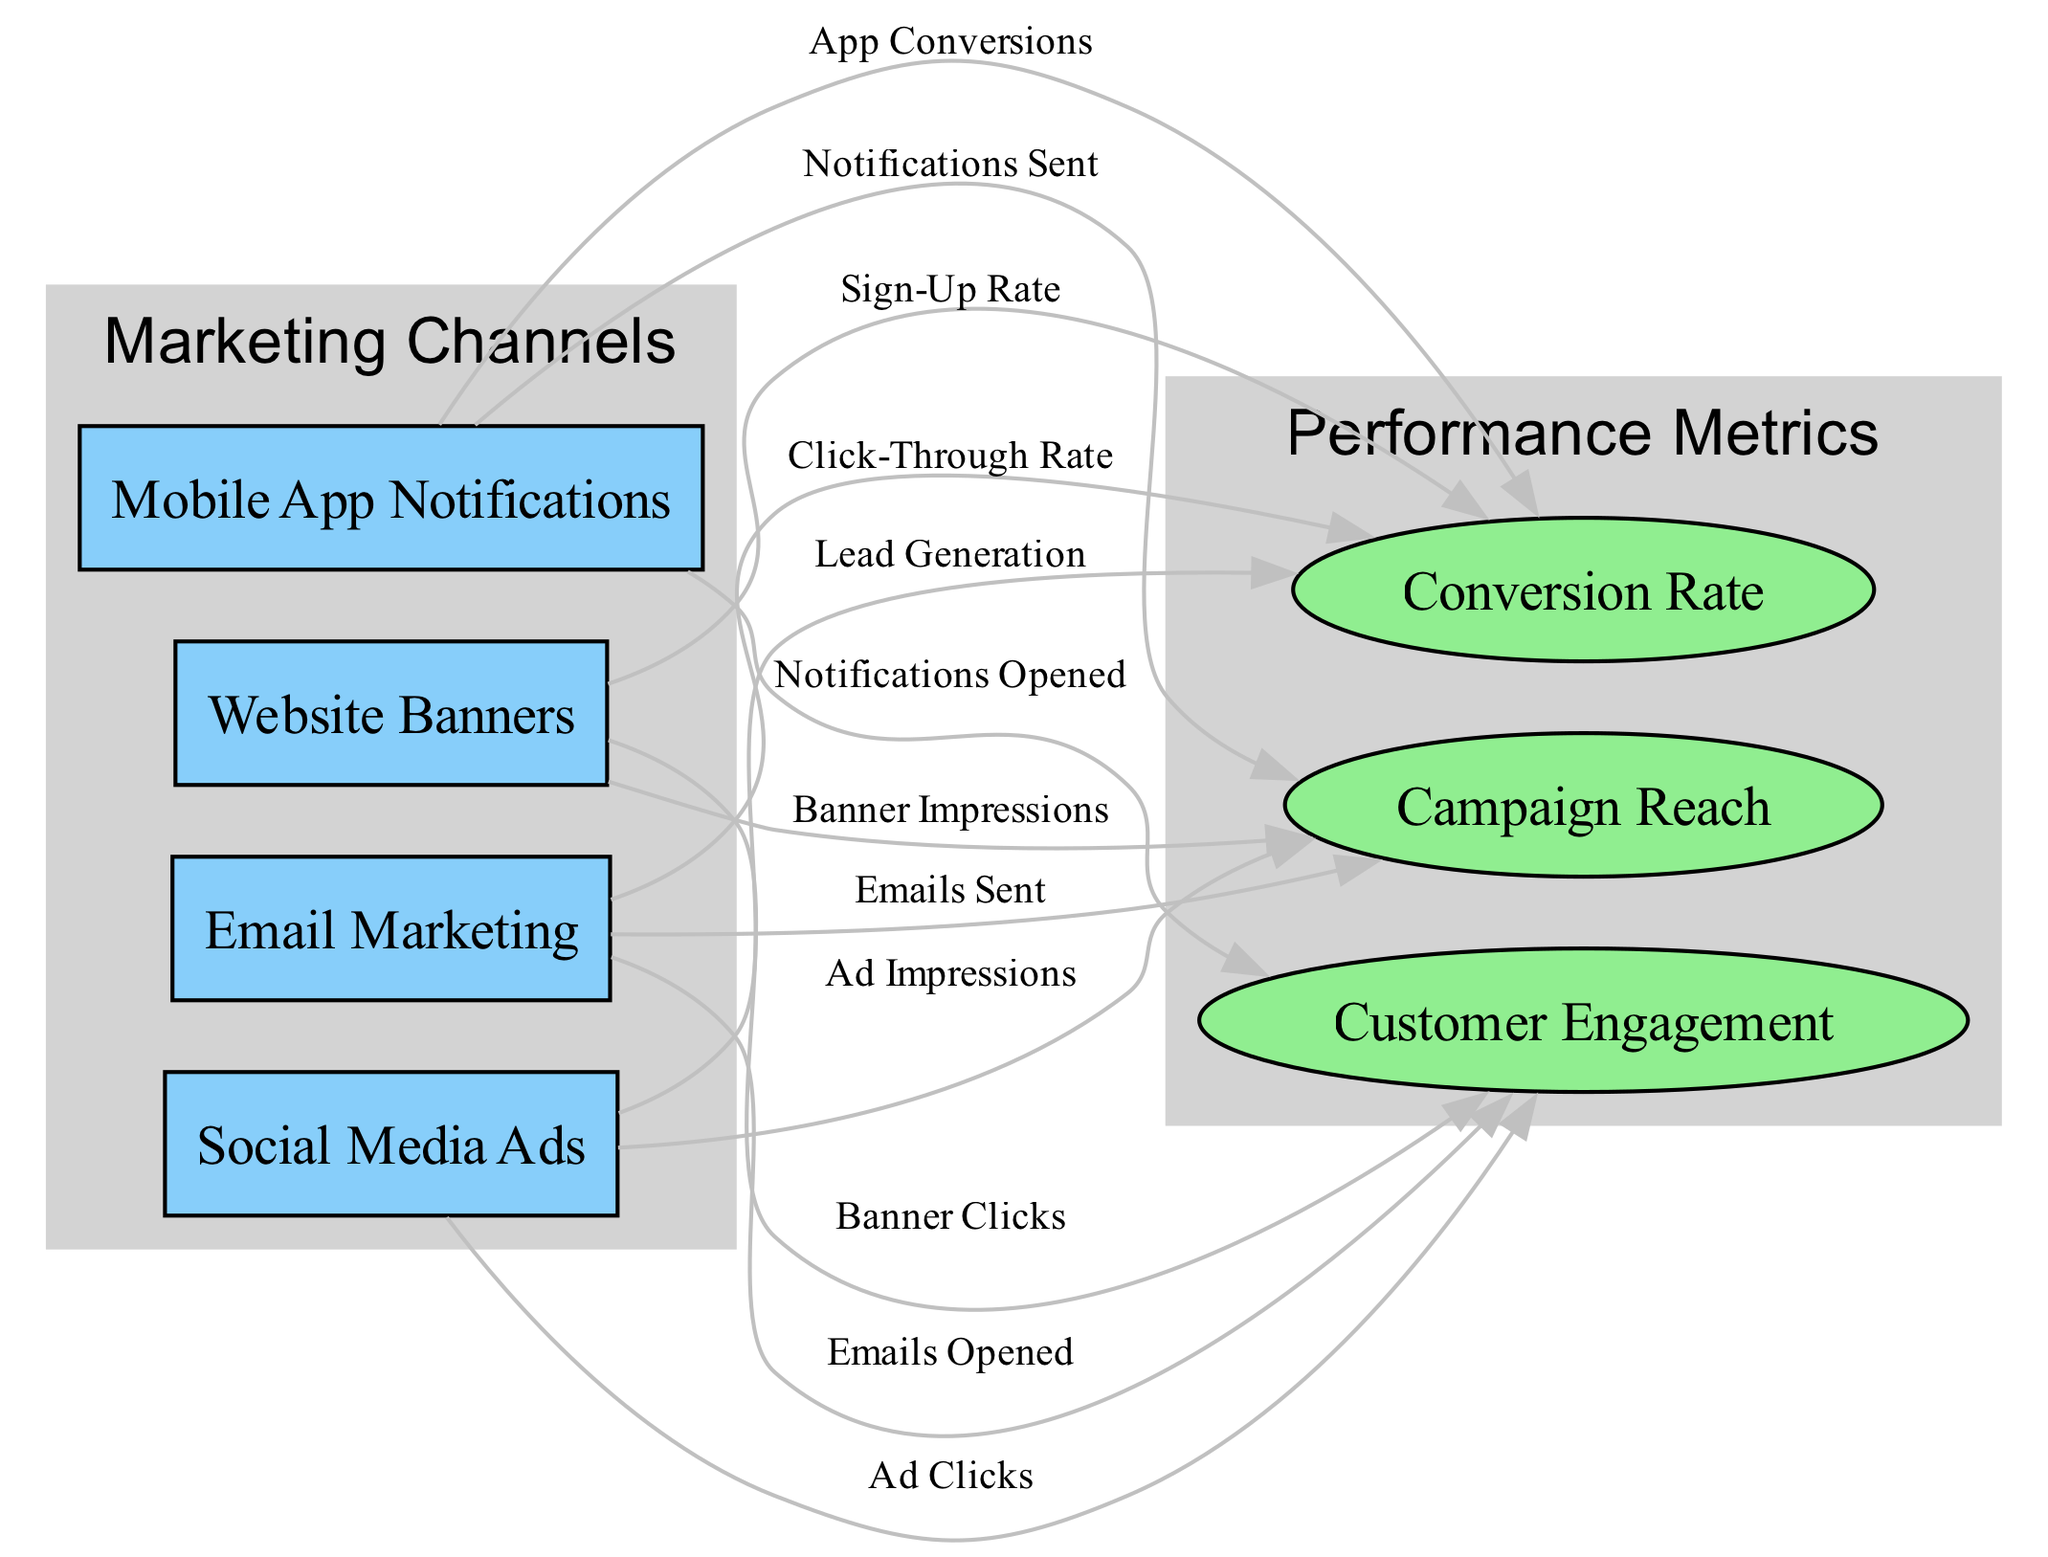What are the four marketing channels represented in the diagram? The nodes for marketing channels are Email Marketing, Social Media Ads, Mobile App Notifications, and Website Banners. These nodes are specifically labeled and grouped together in the 'Marketing Channels' subgraph.
Answer: Email Marketing, Social Media Ads, Mobile App Notifications, Website Banners How many performance metrics are shown in the diagram? There are three performance metrics represented in the diagram: Campaign Reach, Customer Engagement, and Conversion Rate. These are indicated by the three nodes in the 'Performance Metrics' subgraph.
Answer: 3 What is the relationship between Email Marketing and Customer Engagement? The edge from 'Email Marketing' to 'Customer Engagement' is labeled 'Emails Opened', indicating that customer engagement results from the emails opened by recipients. This suggests a direct relationship between the two nodes.
Answer: Emails Opened Which marketing channel has the highest number of engagement metrics? Each marketing channel has a direct relationship with three performance metrics, representing equal engagement. Analyzing the edges shows that all channels connect to Campaign Reach, Customer Engagement, and Conversion Rate. Thus, there is no single channel with more metrics than the others.
Answer: None What is the connection between Social Media Ads and Conversion Rate? The edge from 'Social Media Ads' to 'Conversion Rate' is labeled 'Lead Generation', which illustrates that interactions via social media translate into leads, leading to conversions. Thus, they are directly connected through this edge.
Answer: Lead Generation Which marketing channel connects to the highest number of performance metrics? All four marketing channels - Email Marketing, Social Media Ads, Mobile App Notifications, and Website Banners - connect to the same three performance metrics: Campaign Reach, Customer Engagement, and Conversion Rate. Hence, they are equally connected.
Answer: All are equal What are the metrics related to Mobile App Notifications? Mobile App Notifications connects to three performance metrics: Notifications Sent, Notifications Opened, and App Conversions. Each of these edges denotes a specific action taken regarding notifications.
Answer: Notifications Sent, Notifications Opened, App Conversions What type of diagram is used to visualize Omnichannel Marketing Campaign Efficiency? This diagram is a Textbook Diagram, which is typically designed to illustrate relationships between concepts in a structured manner, making it easy to follow and understand the connections between marketing channels and performance metrics.
Answer: Textbook Diagram 